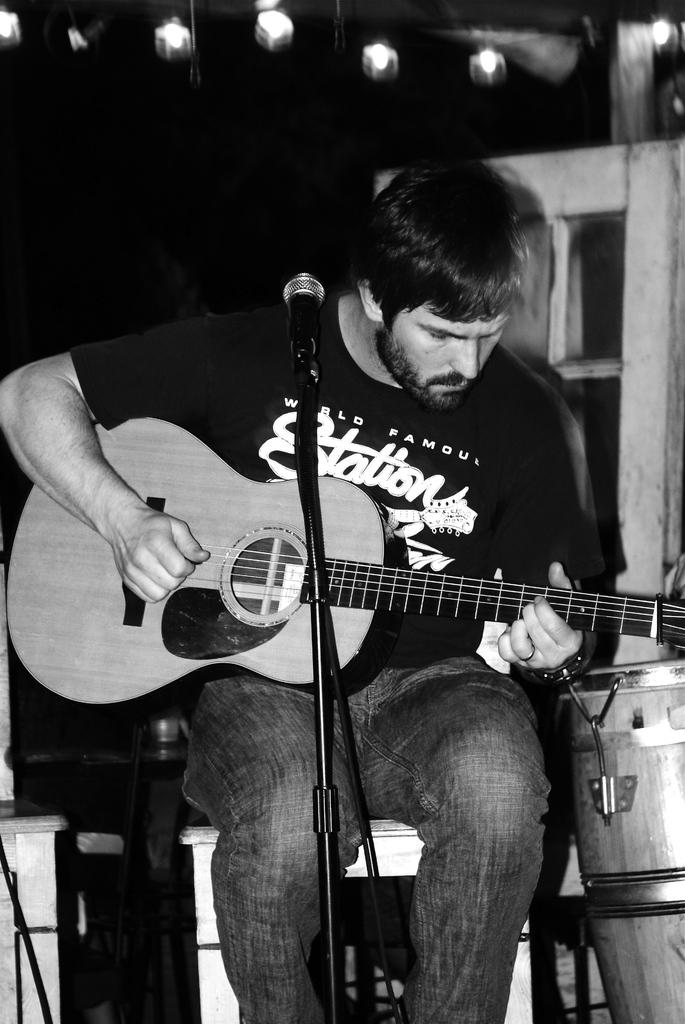What is the person in the image doing? The person is playing a guitar. What is the person wearing in the image? The person is wearing a black shirt. What is the person sitting on in the image? The person is sitting on a stool. What object is in front of the person in the image? There is a microphone in front of the person. How does the person help with the destruction in the image? There is no destruction present in the image, and the person is not helping with any destruction. 